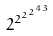Convert formula to latex. <formula><loc_0><loc_0><loc_500><loc_500>2 ^ { 2 ^ { 2 ^ { 2 ^ { 4 3 } } } }</formula> 